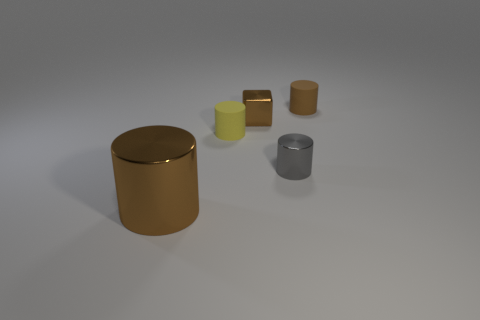Is there anything else that has the same size as the brown metallic cylinder?
Offer a terse response. No. Are there more large brown cylinders to the right of the yellow rubber cylinder than metallic cylinders that are left of the large shiny cylinder?
Your response must be concise. No. Does the gray object have the same shape as the brown object that is in front of the yellow object?
Provide a succinct answer. Yes. There is a brown cylinder behind the cube; does it have the same size as the brown metal thing that is in front of the tiny yellow thing?
Your response must be concise. No. There is a matte thing that is in front of the tiny brown cylinder that is behind the large metal thing; is there a yellow matte object that is behind it?
Your answer should be compact. No. Are there fewer brown metal cylinders that are to the right of the small yellow cylinder than small cylinders that are right of the small gray cylinder?
Make the answer very short. Yes. There is another brown object that is made of the same material as the big thing; what is its shape?
Offer a terse response. Cube. There is a brown metallic object on the right side of the big cylinder that is on the left side of the matte object in front of the small brown shiny cube; what size is it?
Your response must be concise. Small. Is the number of blue spheres greater than the number of tiny yellow cylinders?
Offer a terse response. No. There is a rubber thing that is left of the tiny metallic cylinder; does it have the same color as the tiny cylinder that is behind the tiny yellow rubber thing?
Your answer should be compact. No. 